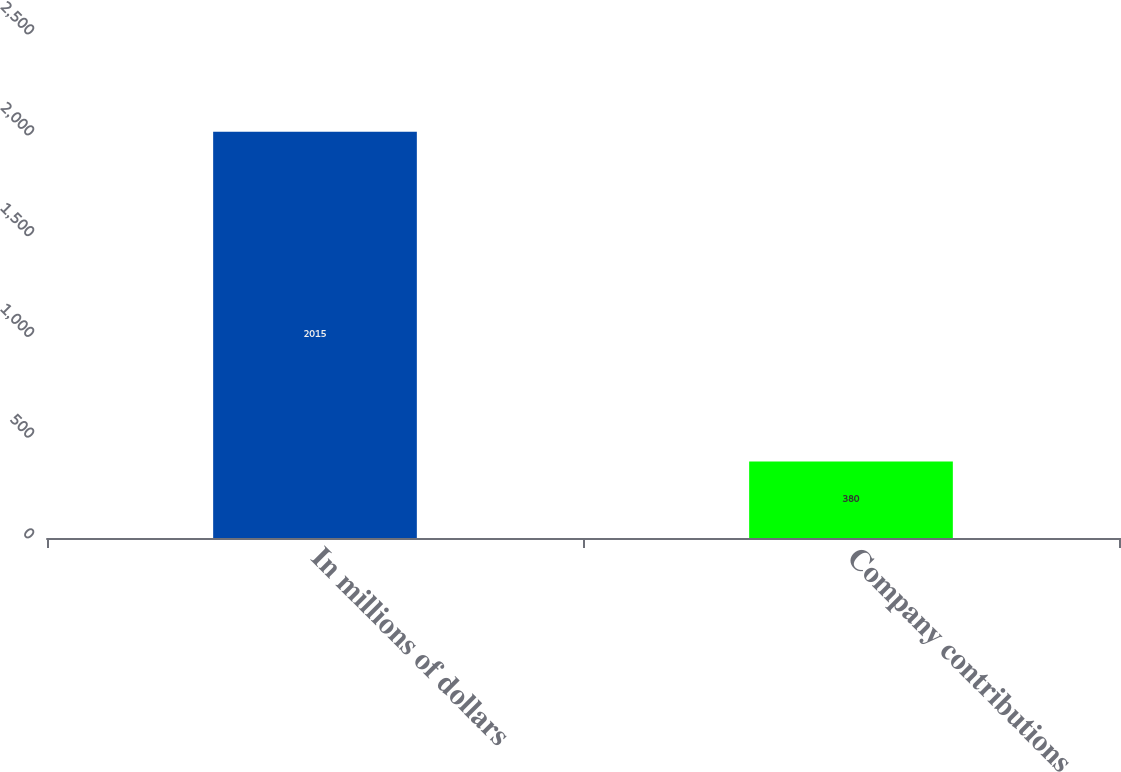Convert chart. <chart><loc_0><loc_0><loc_500><loc_500><bar_chart><fcel>In millions of dollars<fcel>Company contributions<nl><fcel>2015<fcel>380<nl></chart> 